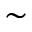<formula> <loc_0><loc_0><loc_500><loc_500>\sim</formula> 